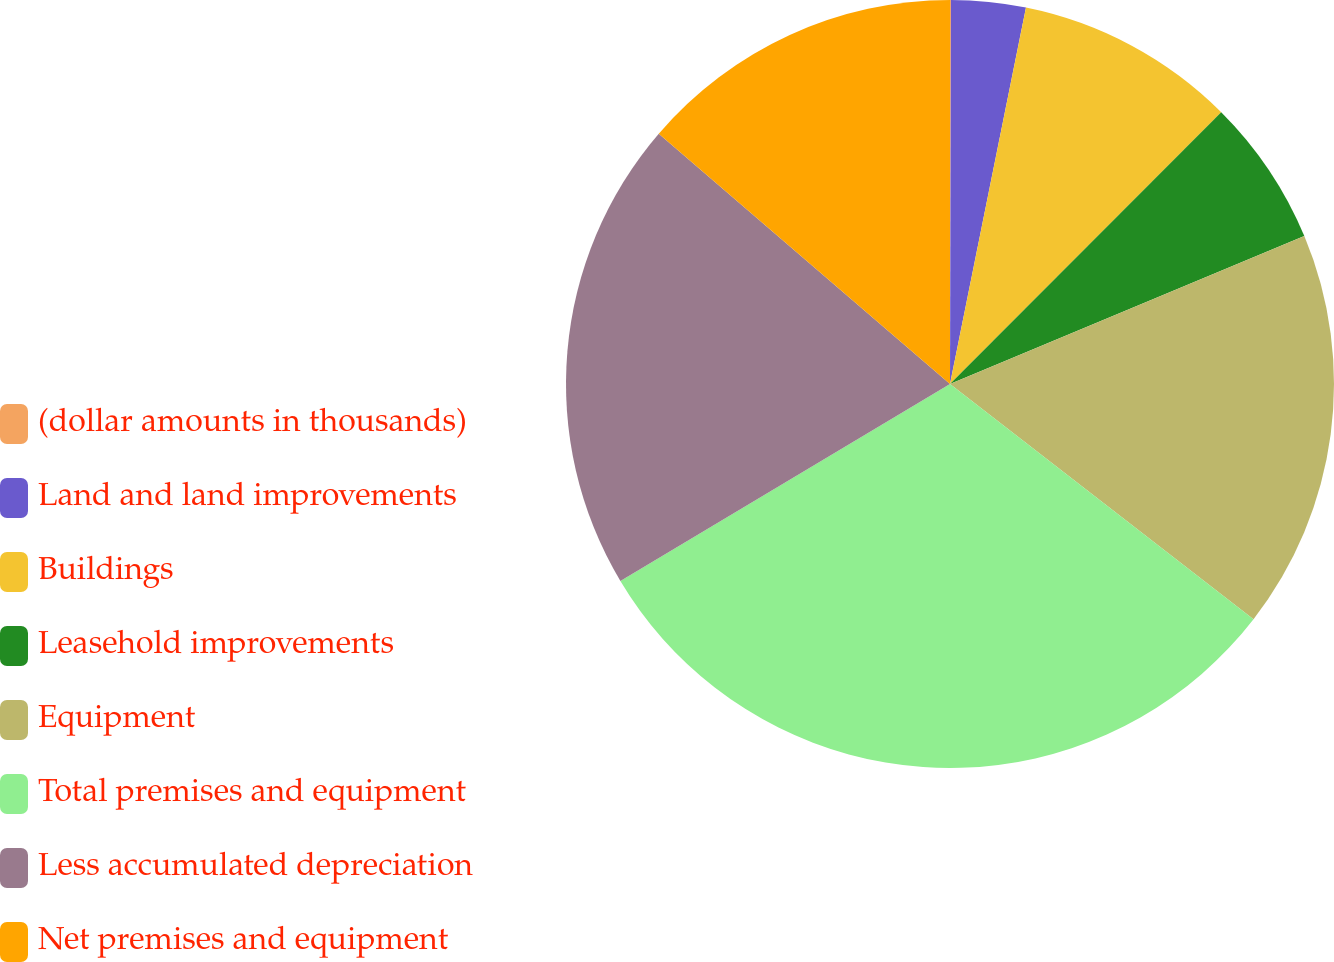Convert chart. <chart><loc_0><loc_0><loc_500><loc_500><pie_chart><fcel>(dollar amounts in thousands)<fcel>Land and land improvements<fcel>Buildings<fcel>Leasehold improvements<fcel>Equipment<fcel>Total premises and equipment<fcel>Less accumulated depreciation<fcel>Net premises and equipment<nl><fcel>0.04%<fcel>3.13%<fcel>9.31%<fcel>6.22%<fcel>16.79%<fcel>30.93%<fcel>19.87%<fcel>13.7%<nl></chart> 